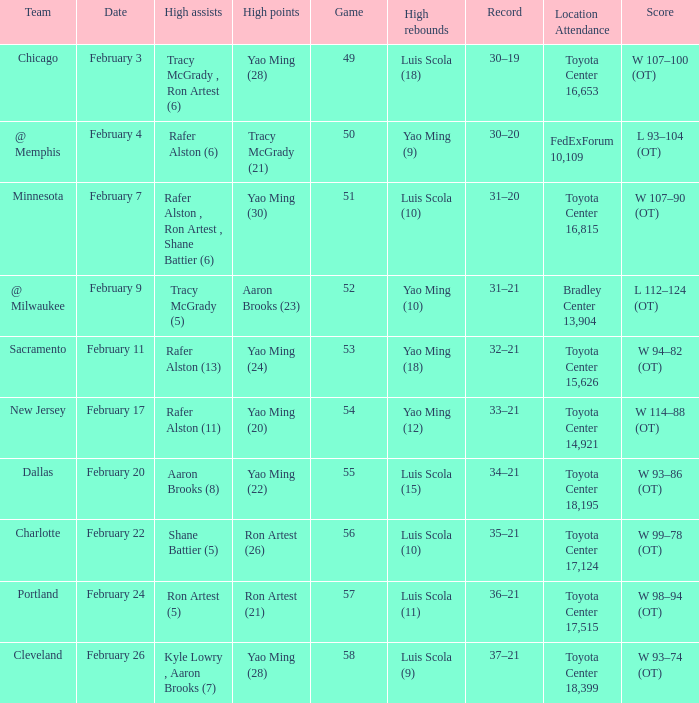Name the record for score of  l 93–104 (ot) 30–20. 